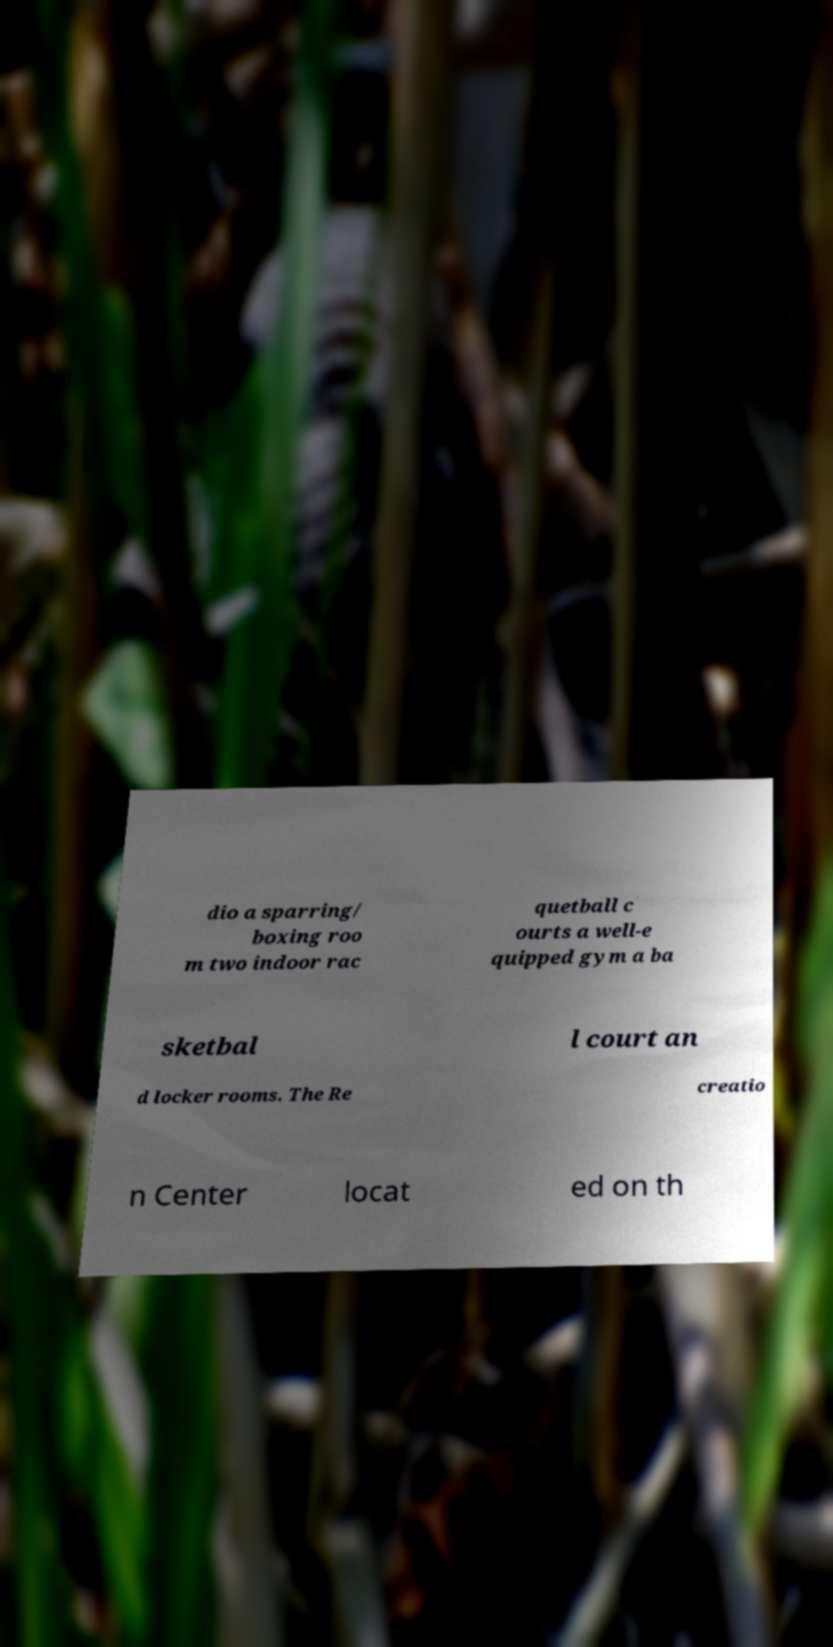What messages or text are displayed in this image? I need them in a readable, typed format. dio a sparring/ boxing roo m two indoor rac quetball c ourts a well-e quipped gym a ba sketbal l court an d locker rooms. The Re creatio n Center locat ed on th 